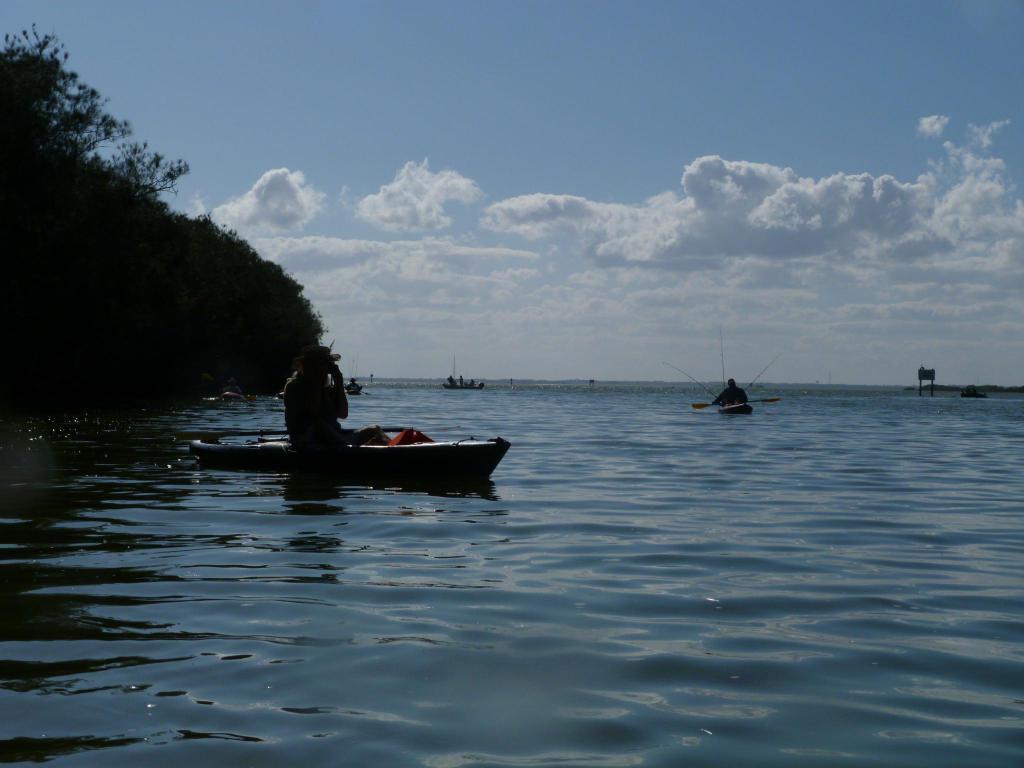Please provide a concise description of this image. In this picture we can see some people sitting on the boats and the boats are on the water. On the left side of the people there are trees and a sky. 